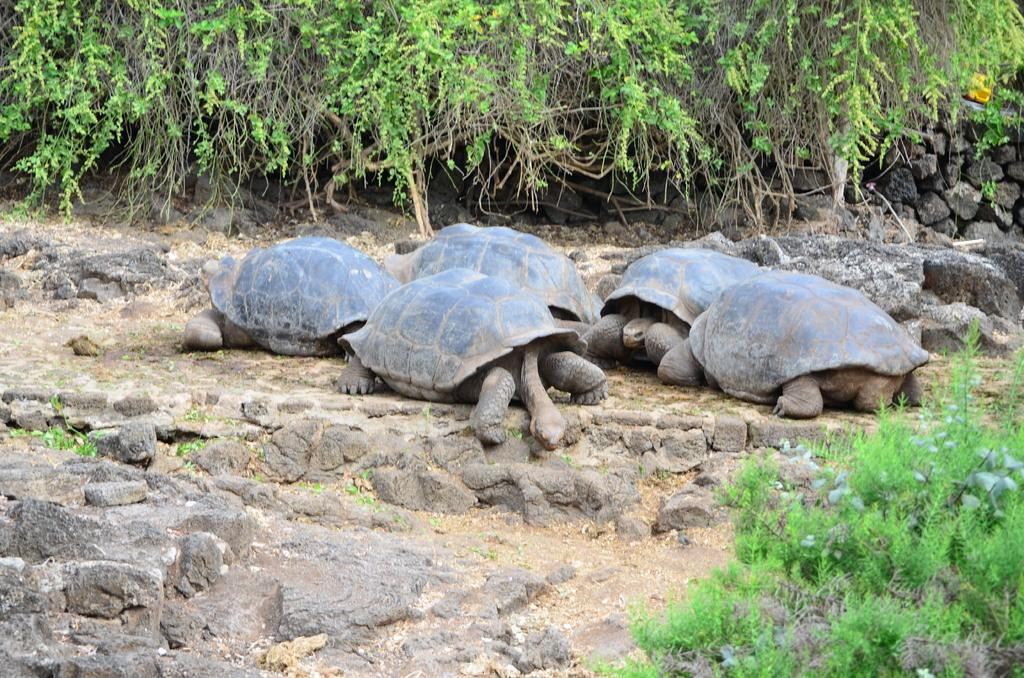What type of animals can be seen on the ground in the image? There are tortoises on the ground in the image. What else can be seen on the ground in the image? There are stones visible in the image. What type of vegetation is present in the image? There is a group of plants in the image. What type of dog can be seen playing with a heart-shaped ball in the image? There is no dog or heart-shaped ball present in the image; it features tortoises, stones, and a group of plants. 